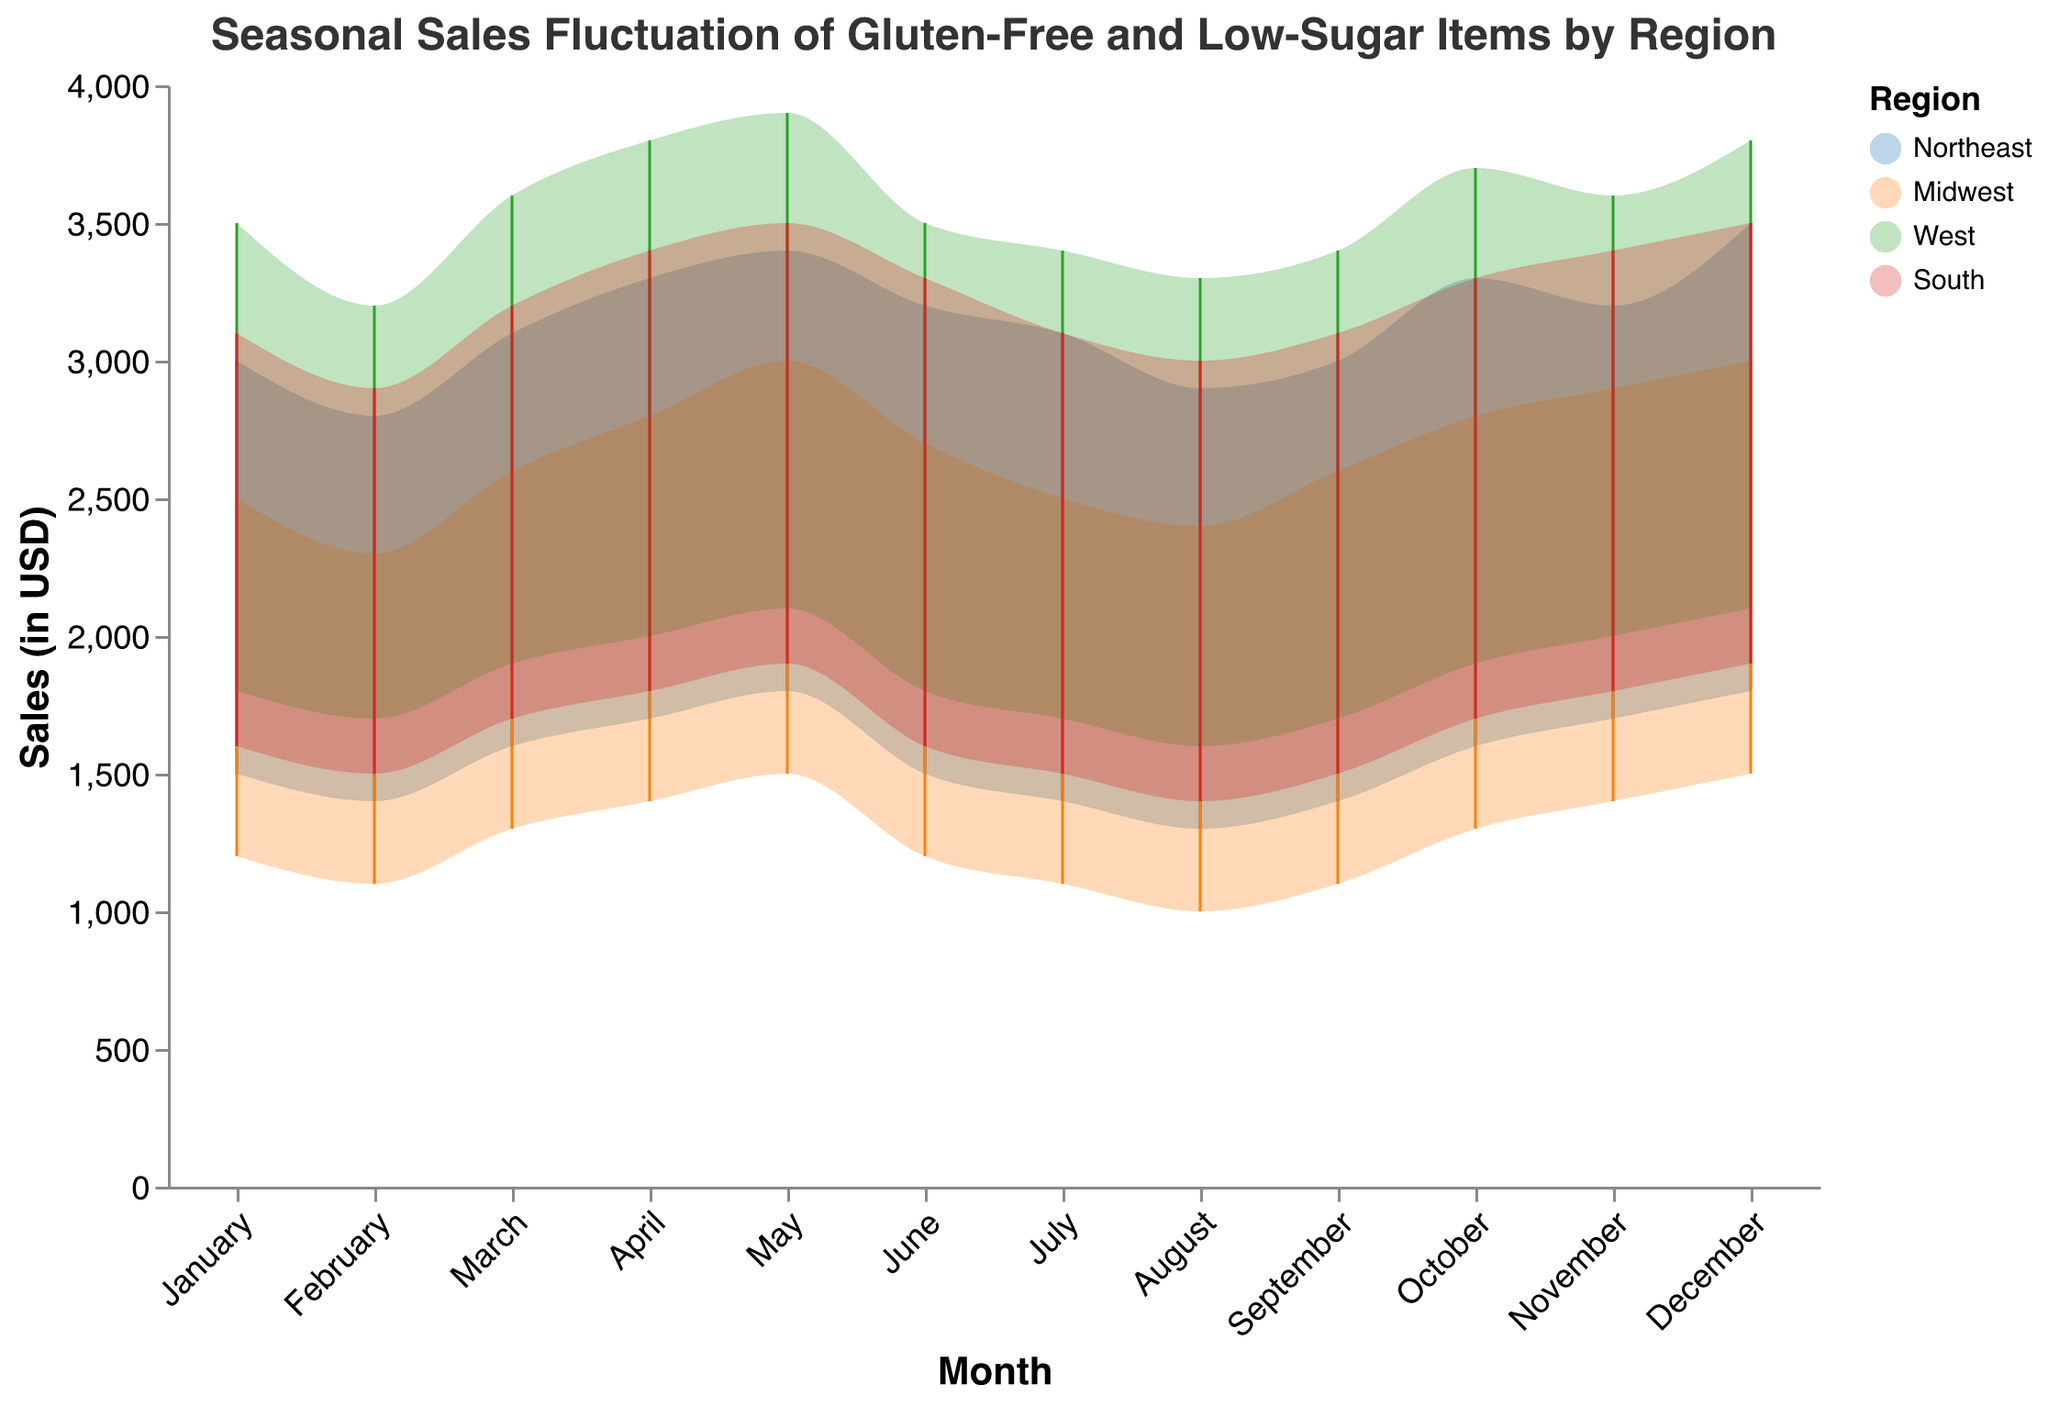What is the title of the chart? The title of the chart is generally located at the top and provides a summary of the figure's purpose or content. In this case, the title clearly indicates the subject of the chart.
Answer: Seasonal Sales Fluctuation of Gluten-Free and Low-Sugar Items by Region During which month does the Northeast region have the maximum sales peak? By examining the range areas and peaks for each month associated with the Northeast region, December has the highest maximum sales value of 3500 USD.
Answer: December How does the sales fluctuation of the Midwest region in May compare to June? We need to look at both the minimum and maximum sales in May and June for the Midwest region. In May, the range is 1500 to 3000, while in June, it is 1200 to 2700, showing lower sales in June compared to May.
Answer: Sales in June are lower than in May Which region has the highest minimum sales in January? We check the minimum sales for all regions in January and observe that the West region has the highest minimum sales of 1800 USD.
Answer: West Is there a month where all regions have an increase in maximum sales compared to the previous month? Examine the max sales values month over month for each region and determine if all regions exhibit an increase from one month to the next. April has this characteristic; the max sales in April for all regions are higher than those in March.
Answer: April In which months do the South and Northeast regions exhibit the same maximum sales value? Compare the maximum sales values of the South and Northeast regions across all months and identify any months where they match. Both regions exhibit a maximum sales value of 3500 USD in December.
Answer: December Calculate the average maximum sales value for the West region across the entire year. Sum all the maximum sales values for the West region (3500 + 3200 + 3600 + 3800 + 3900 + 3500 + 3400 + 3300 + 3400 + 3700 + 3600 + 3800 = 42700) and divide by 12 (months).
Answer: 3558.33 For which months does the Northeast region have a lower minimum sales value compared to the Midwest? Compare the minimum sales for both regions month by month and identify where the Northeast values are lower. - August (Northeast: 1300 vs. Midwest: 1000) - September (Northeast: 1400 vs. Midwest: 1100) - October (Northeast: 1600 vs. Midwest: 1300) - November (Northeast: 1700 vs. Midwest: 1400) - December (Northeast: 1800 vs. Midwest: 1500)
Answer: August, September, October, November, December Describe the seasonal trend for gluten-free and low-sugar items in the Northeast region. Observe the peaks and troughs of sales values over the months to determine the trend. Sales peak in December and hit the lowest in August, indicating stronger sales in winter and weaker in late summer.
Answer: Peaks in December, lowest in August 